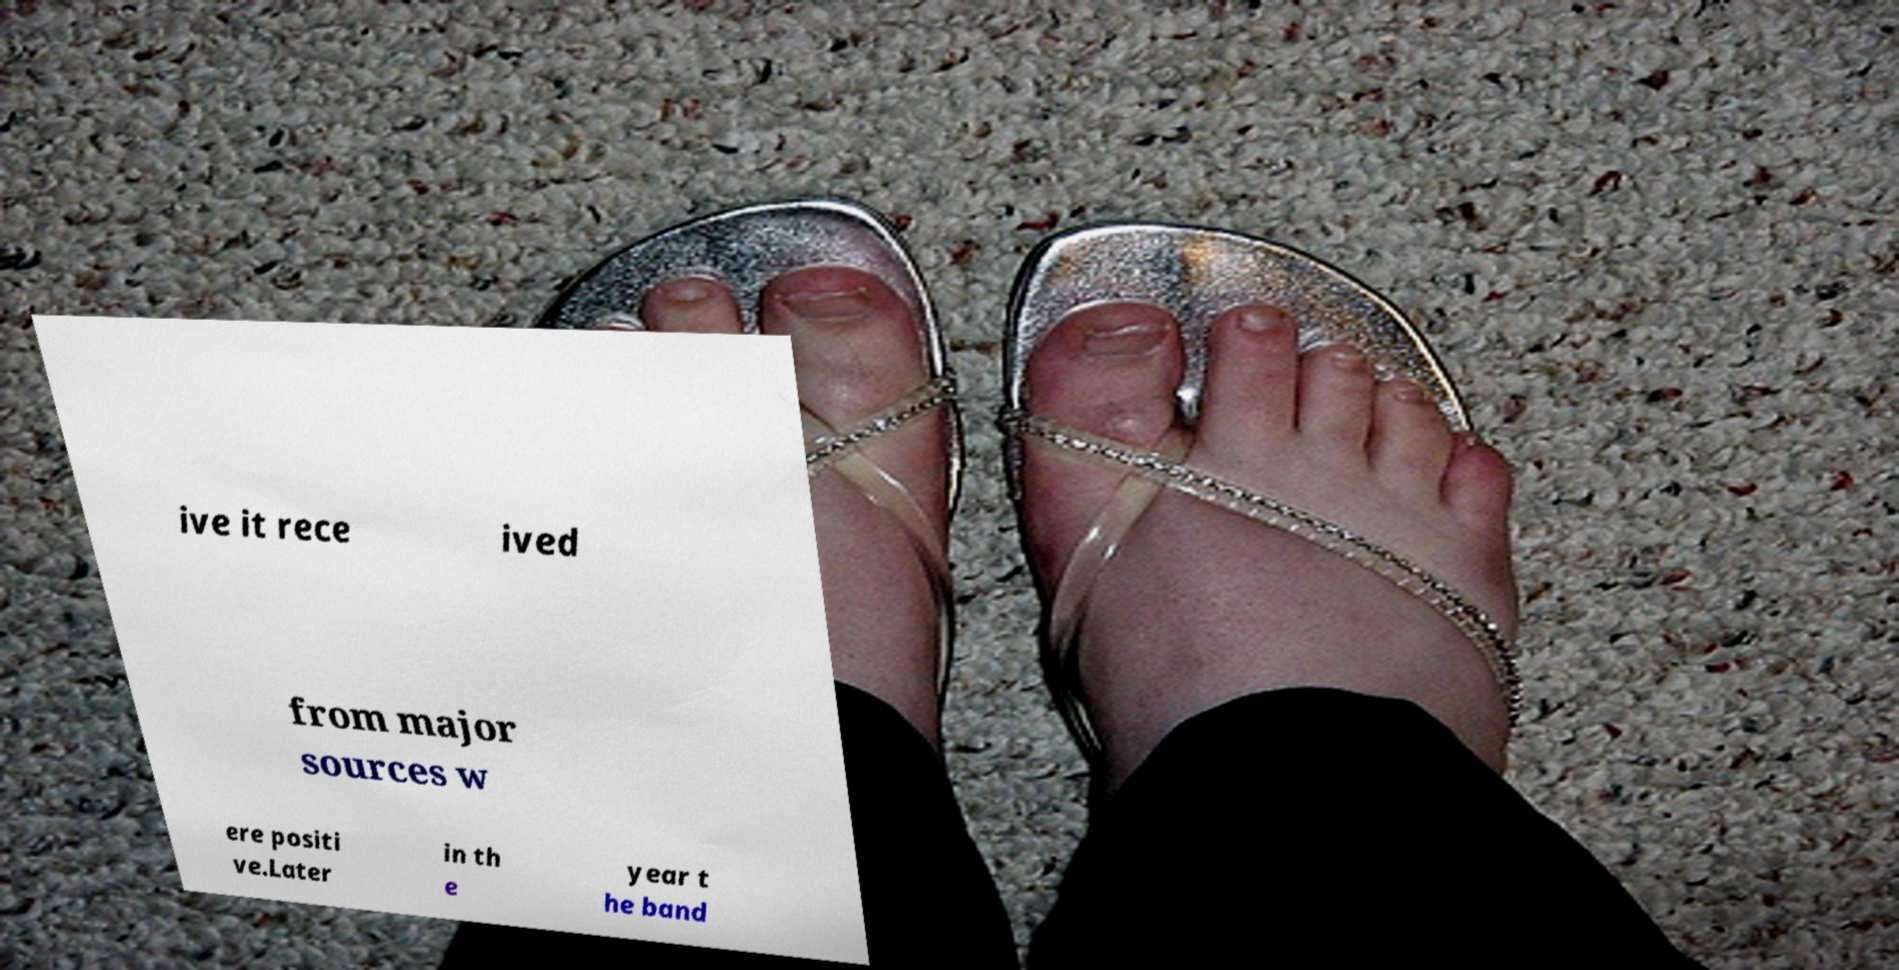Can you read and provide the text displayed in the image?This photo seems to have some interesting text. Can you extract and type it out for me? ive it rece ived from major sources w ere positi ve.Later in th e year t he band 